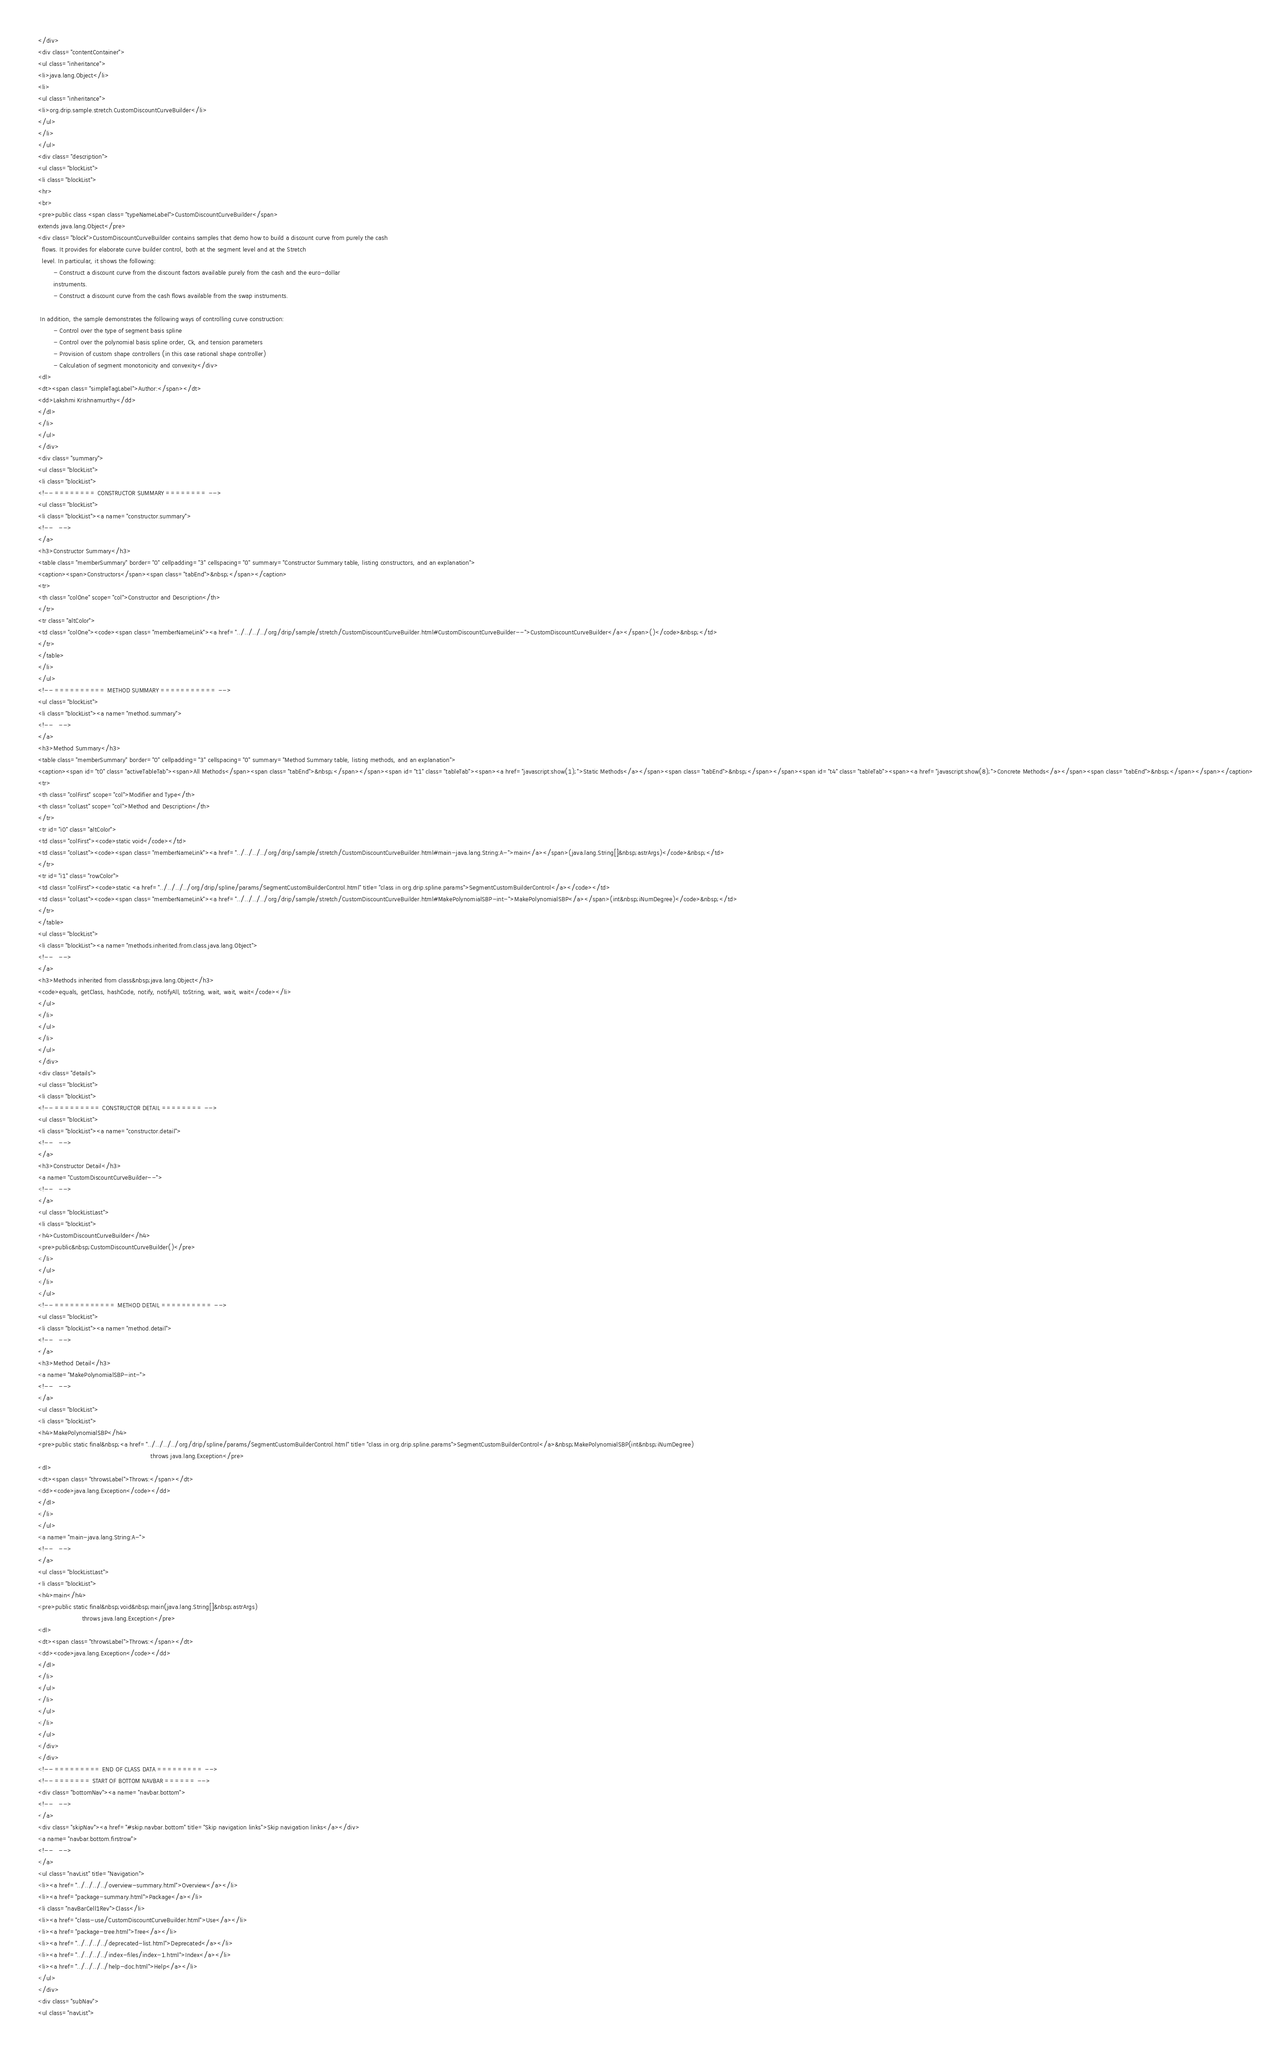Convert code to text. <code><loc_0><loc_0><loc_500><loc_500><_HTML_></div>
<div class="contentContainer">
<ul class="inheritance">
<li>java.lang.Object</li>
<li>
<ul class="inheritance">
<li>org.drip.sample.stretch.CustomDiscountCurveBuilder</li>
</ul>
</li>
</ul>
<div class="description">
<ul class="blockList">
<li class="blockList">
<hr>
<br>
<pre>public class <span class="typeNameLabel">CustomDiscountCurveBuilder</span>
extends java.lang.Object</pre>
<div class="block">CustomDiscountCurveBuilder contains samples that demo how to build a discount curve from purely the cash
  flows. It provides for elaborate curve builder control, both at the segment level and at the Stretch
  level. In particular, it shows the following:
        - Construct a discount curve from the discount factors available purely from the cash and the euro-dollar
        instruments.
        - Construct a discount curve from the cash flows available from the swap instruments.
 
 In addition, the sample demonstrates the following ways of controlling curve construction:
        - Control over the type of segment basis spline
        - Control over the polynomial basis spline order, Ck, and tension parameters
        - Provision of custom shape controllers (in this case rational shape controller)
        - Calculation of segment monotonicity and convexity</div>
<dl>
<dt><span class="simpleTagLabel">Author:</span></dt>
<dd>Lakshmi Krishnamurthy</dd>
</dl>
</li>
</ul>
</div>
<div class="summary">
<ul class="blockList">
<li class="blockList">
<!-- ======== CONSTRUCTOR SUMMARY ======== -->
<ul class="blockList">
<li class="blockList"><a name="constructor.summary">
<!--   -->
</a>
<h3>Constructor Summary</h3>
<table class="memberSummary" border="0" cellpadding="3" cellspacing="0" summary="Constructor Summary table, listing constructors, and an explanation">
<caption><span>Constructors</span><span class="tabEnd">&nbsp;</span></caption>
<tr>
<th class="colOne" scope="col">Constructor and Description</th>
</tr>
<tr class="altColor">
<td class="colOne"><code><span class="memberNameLink"><a href="../../../../org/drip/sample/stretch/CustomDiscountCurveBuilder.html#CustomDiscountCurveBuilder--">CustomDiscountCurveBuilder</a></span>()</code>&nbsp;</td>
</tr>
</table>
</li>
</ul>
<!-- ========== METHOD SUMMARY =========== -->
<ul class="blockList">
<li class="blockList"><a name="method.summary">
<!--   -->
</a>
<h3>Method Summary</h3>
<table class="memberSummary" border="0" cellpadding="3" cellspacing="0" summary="Method Summary table, listing methods, and an explanation">
<caption><span id="t0" class="activeTableTab"><span>All Methods</span><span class="tabEnd">&nbsp;</span></span><span id="t1" class="tableTab"><span><a href="javascript:show(1);">Static Methods</a></span><span class="tabEnd">&nbsp;</span></span><span id="t4" class="tableTab"><span><a href="javascript:show(8);">Concrete Methods</a></span><span class="tabEnd">&nbsp;</span></span></caption>
<tr>
<th class="colFirst" scope="col">Modifier and Type</th>
<th class="colLast" scope="col">Method and Description</th>
</tr>
<tr id="i0" class="altColor">
<td class="colFirst"><code>static void</code></td>
<td class="colLast"><code><span class="memberNameLink"><a href="../../../../org/drip/sample/stretch/CustomDiscountCurveBuilder.html#main-java.lang.String:A-">main</a></span>(java.lang.String[]&nbsp;astrArgs)</code>&nbsp;</td>
</tr>
<tr id="i1" class="rowColor">
<td class="colFirst"><code>static <a href="../../../../org/drip/spline/params/SegmentCustomBuilderControl.html" title="class in org.drip.spline.params">SegmentCustomBuilderControl</a></code></td>
<td class="colLast"><code><span class="memberNameLink"><a href="../../../../org/drip/sample/stretch/CustomDiscountCurveBuilder.html#MakePolynomialSBP-int-">MakePolynomialSBP</a></span>(int&nbsp;iNumDegree)</code>&nbsp;</td>
</tr>
</table>
<ul class="blockList">
<li class="blockList"><a name="methods.inherited.from.class.java.lang.Object">
<!--   -->
</a>
<h3>Methods inherited from class&nbsp;java.lang.Object</h3>
<code>equals, getClass, hashCode, notify, notifyAll, toString, wait, wait, wait</code></li>
</ul>
</li>
</ul>
</li>
</ul>
</div>
<div class="details">
<ul class="blockList">
<li class="blockList">
<!-- ========= CONSTRUCTOR DETAIL ======== -->
<ul class="blockList">
<li class="blockList"><a name="constructor.detail">
<!--   -->
</a>
<h3>Constructor Detail</h3>
<a name="CustomDiscountCurveBuilder--">
<!--   -->
</a>
<ul class="blockListLast">
<li class="blockList">
<h4>CustomDiscountCurveBuilder</h4>
<pre>public&nbsp;CustomDiscountCurveBuilder()</pre>
</li>
</ul>
</li>
</ul>
<!-- ============ METHOD DETAIL ========== -->
<ul class="blockList">
<li class="blockList"><a name="method.detail">
<!--   -->
</a>
<h3>Method Detail</h3>
<a name="MakePolynomialSBP-int-">
<!--   -->
</a>
<ul class="blockList">
<li class="blockList">
<h4>MakePolynomialSBP</h4>
<pre>public static final&nbsp;<a href="../../../../org/drip/spline/params/SegmentCustomBuilderControl.html" title="class in org.drip.spline.params">SegmentCustomBuilderControl</a>&nbsp;MakePolynomialSBP(int&nbsp;iNumDegree)
                                                           throws java.lang.Exception</pre>
<dl>
<dt><span class="throwsLabel">Throws:</span></dt>
<dd><code>java.lang.Exception</code></dd>
</dl>
</li>
</ul>
<a name="main-java.lang.String:A-">
<!--   -->
</a>
<ul class="blockListLast">
<li class="blockList">
<h4>main</h4>
<pre>public static final&nbsp;void&nbsp;main(java.lang.String[]&nbsp;astrArgs)
                       throws java.lang.Exception</pre>
<dl>
<dt><span class="throwsLabel">Throws:</span></dt>
<dd><code>java.lang.Exception</code></dd>
</dl>
</li>
</ul>
</li>
</ul>
</li>
</ul>
</div>
</div>
<!-- ========= END OF CLASS DATA ========= -->
<!-- ======= START OF BOTTOM NAVBAR ====== -->
<div class="bottomNav"><a name="navbar.bottom">
<!--   -->
</a>
<div class="skipNav"><a href="#skip.navbar.bottom" title="Skip navigation links">Skip navigation links</a></div>
<a name="navbar.bottom.firstrow">
<!--   -->
</a>
<ul class="navList" title="Navigation">
<li><a href="../../../../overview-summary.html">Overview</a></li>
<li><a href="package-summary.html">Package</a></li>
<li class="navBarCell1Rev">Class</li>
<li><a href="class-use/CustomDiscountCurveBuilder.html">Use</a></li>
<li><a href="package-tree.html">Tree</a></li>
<li><a href="../../../../deprecated-list.html">Deprecated</a></li>
<li><a href="../../../../index-files/index-1.html">Index</a></li>
<li><a href="../../../../help-doc.html">Help</a></li>
</ul>
</div>
<div class="subNav">
<ul class="navList"></code> 